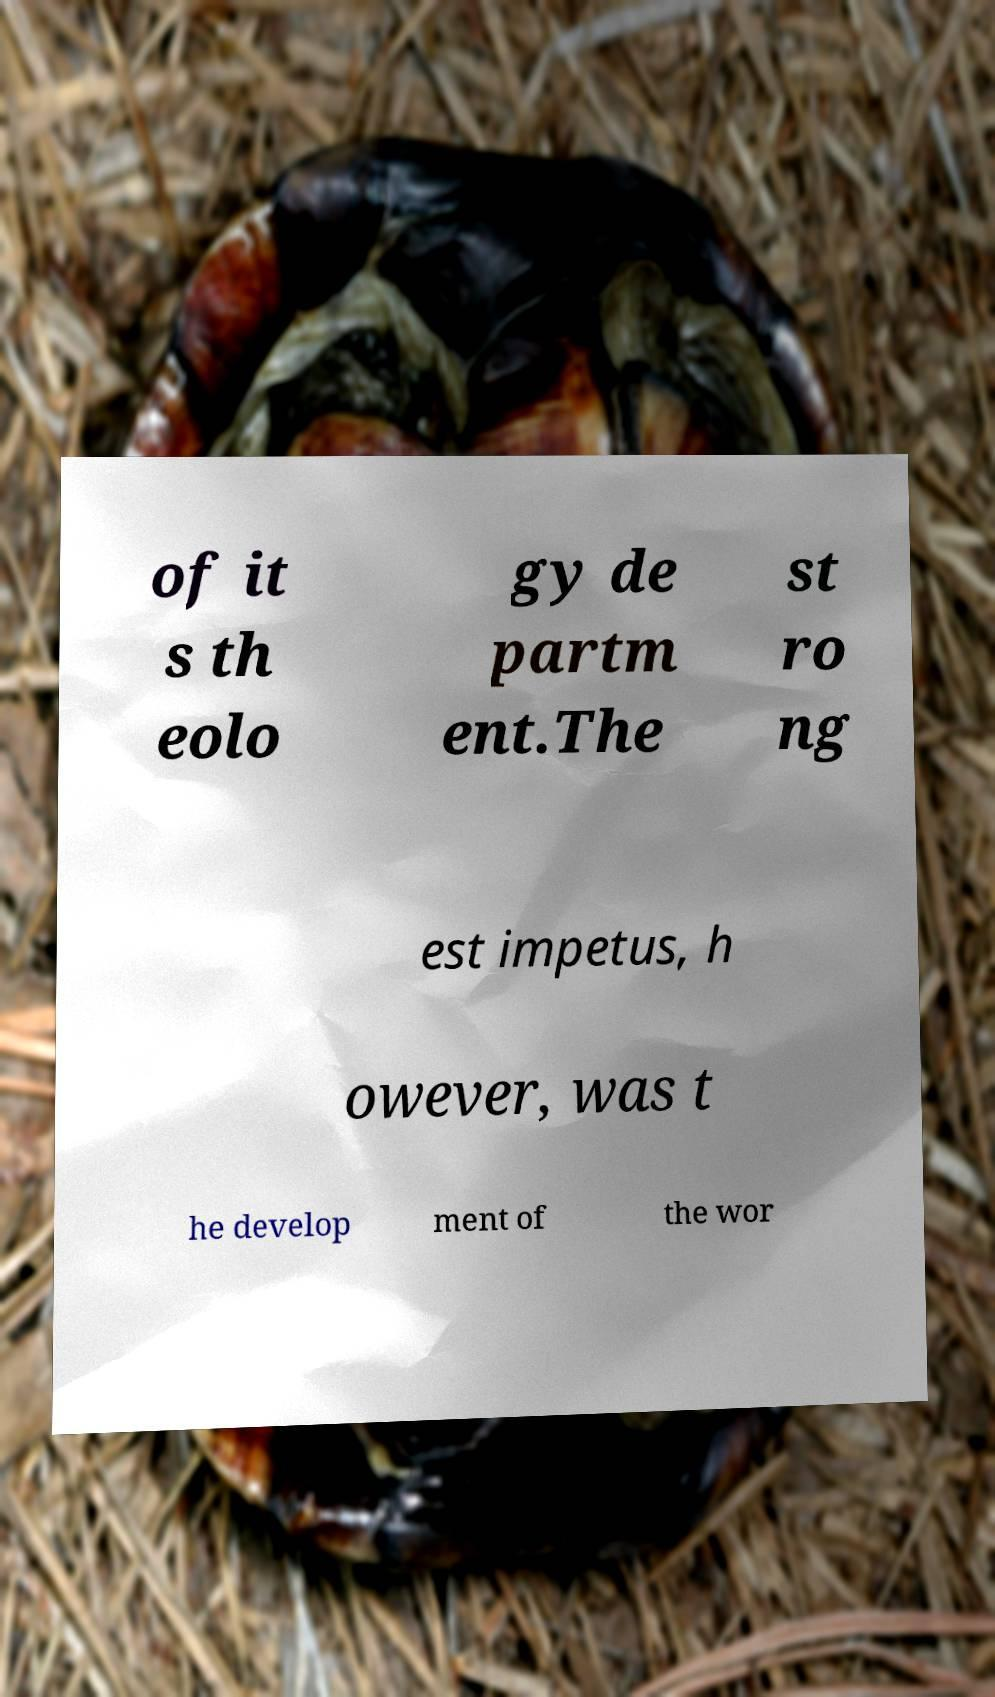Could you assist in decoding the text presented in this image and type it out clearly? of it s th eolo gy de partm ent.The st ro ng est impetus, h owever, was t he develop ment of the wor 